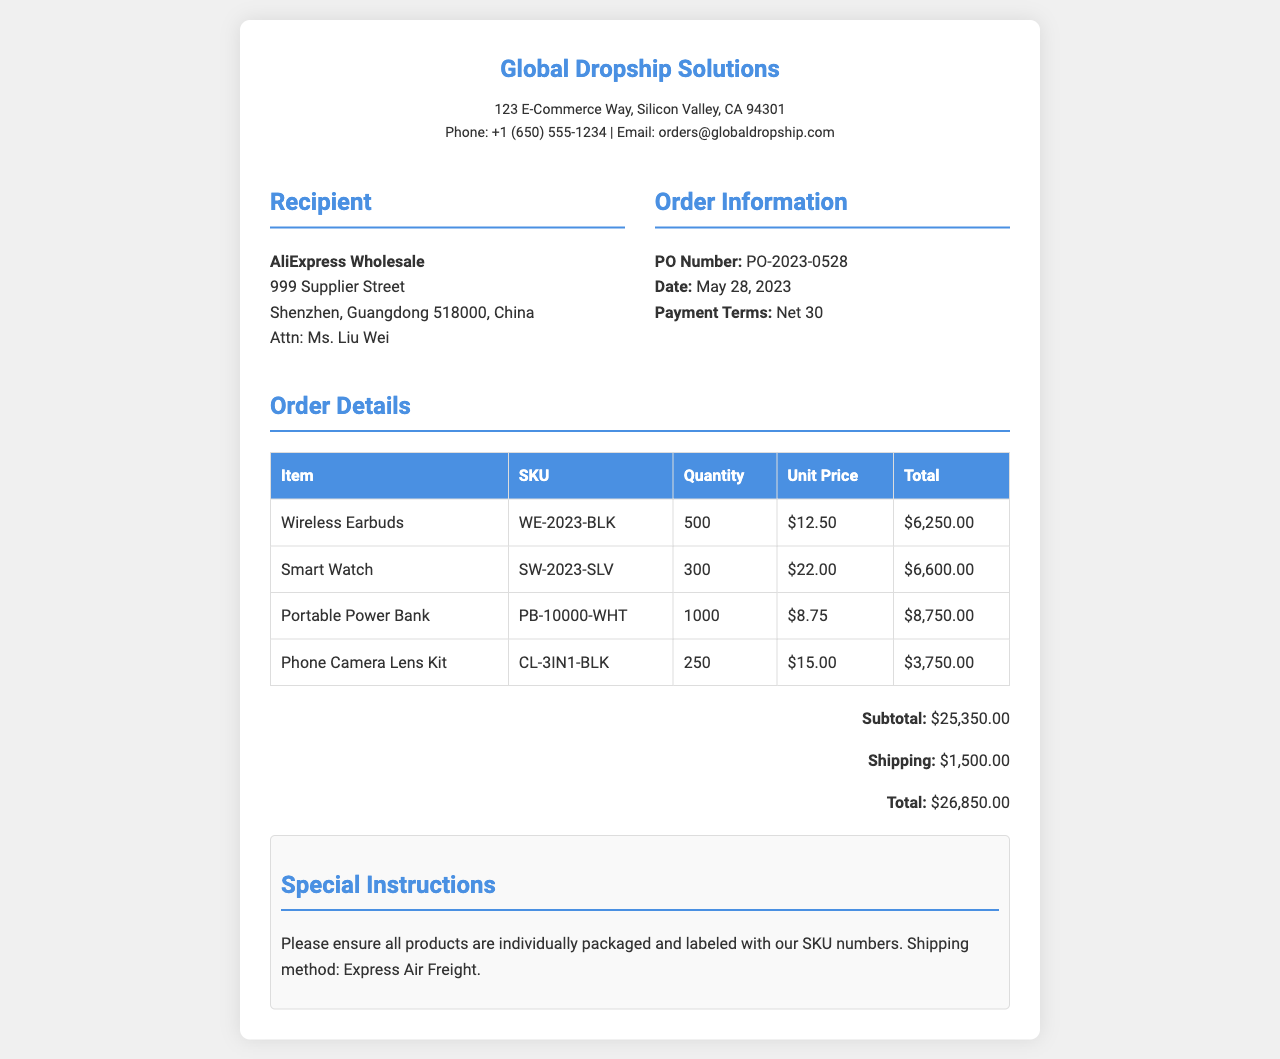What is the PO Number? The PO Number is specified in the order information section of the document.
Answer: PO-2023-0528 Who is the recipient of the order? The recipient details are provided in the document.
Answer: AliExpress Wholesale What is the total amount for the order? The total is listed in the document under totals.
Answer: $26,850.00 How many Wireless Earbuds are ordered? The quantity for each item is specified in the order details table.
Answer: 500 What is the shipping cost? The shipping cost is outlined in the totals section of the document.
Answer: $1,500.00 What is the date of the order? The date is mentioned in the order information section.
Answer: May 28, 2023 What special instructions are noted in the document? Special instructions are provided towards the end of the document.
Answer: Please ensure all products are individually packaged and labeled with our SKU numbers What is the unit price of the Smart Watch? The unit price can be found in the order details table.
Answer: $22.00 How many items are included in the shipment? The total quantity can be calculated by summing the quantities listed for each product in the order details.
Answer: 2050 